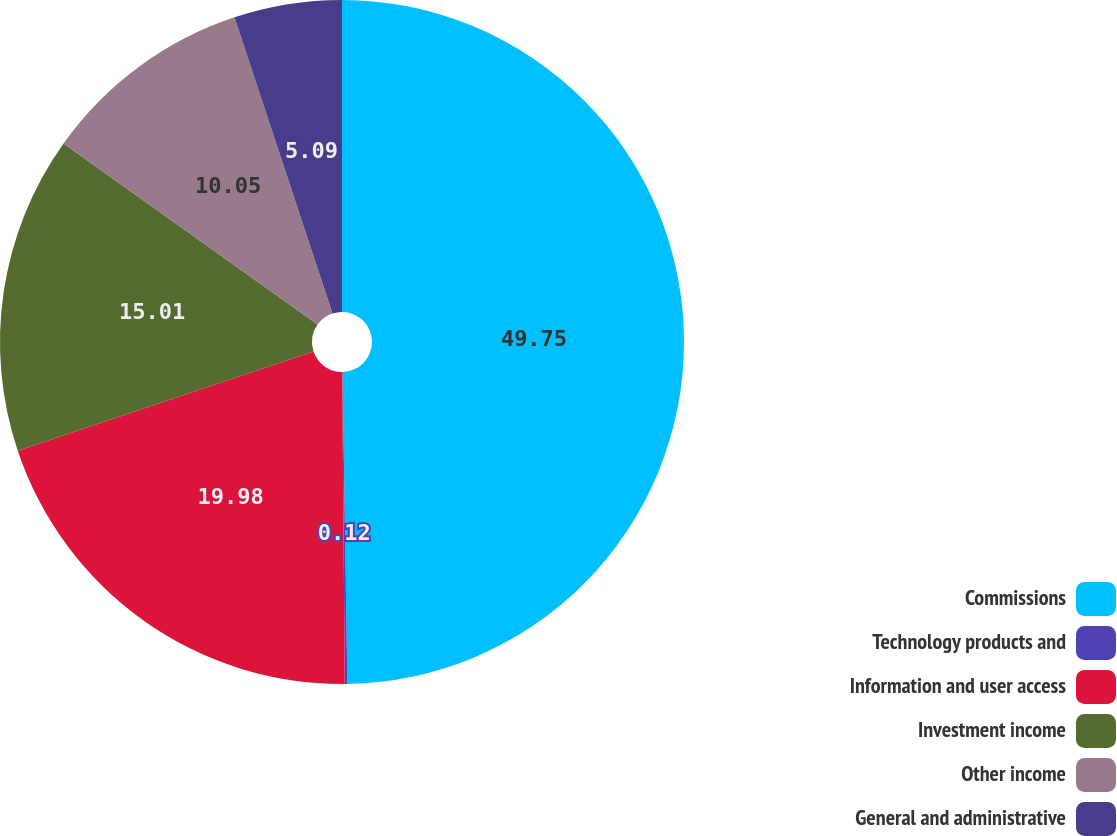Convert chart to OTSL. <chart><loc_0><loc_0><loc_500><loc_500><pie_chart><fcel>Commissions<fcel>Technology products and<fcel>Information and user access<fcel>Investment income<fcel>Other income<fcel>General and administrative<nl><fcel>49.75%<fcel>0.12%<fcel>19.98%<fcel>15.01%<fcel>10.05%<fcel>5.09%<nl></chart> 